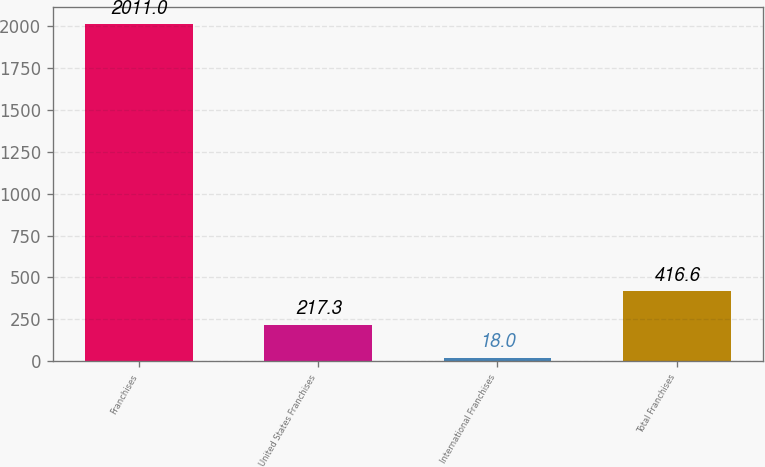Convert chart to OTSL. <chart><loc_0><loc_0><loc_500><loc_500><bar_chart><fcel>Franchises<fcel>United States Franchises<fcel>International Franchises<fcel>Total Franchises<nl><fcel>2011<fcel>217.3<fcel>18<fcel>416.6<nl></chart> 